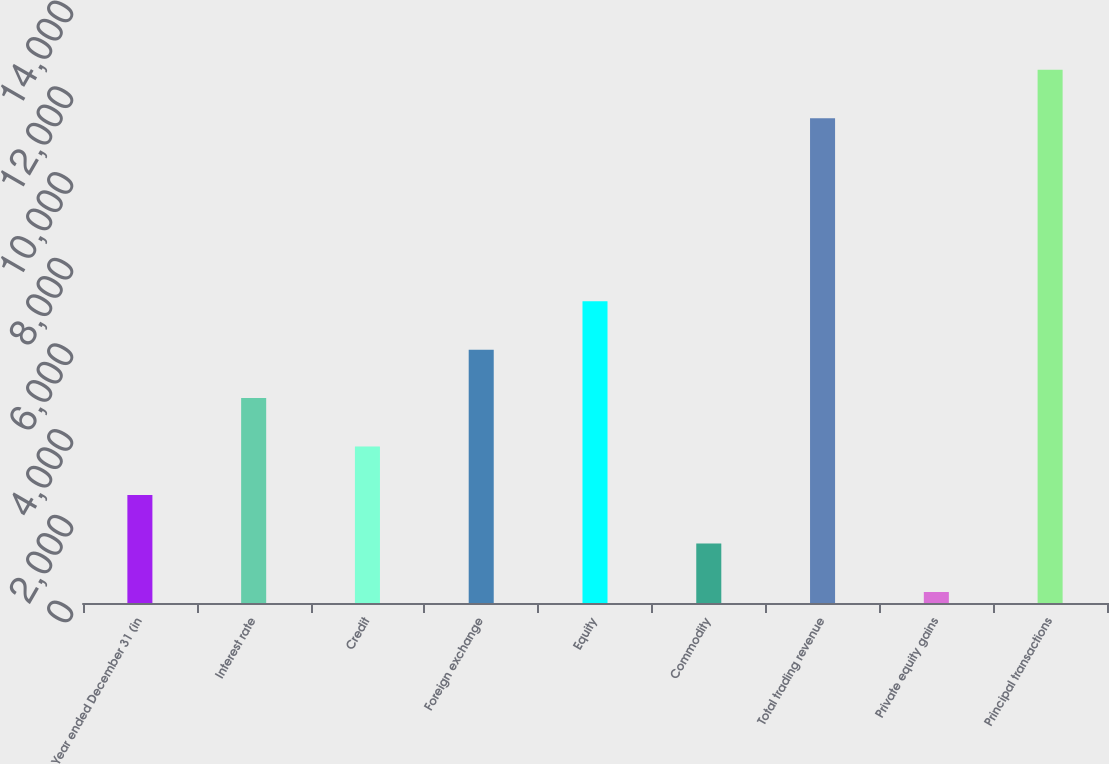<chart> <loc_0><loc_0><loc_500><loc_500><bar_chart><fcel>Year ended December 31 (in<fcel>Interest rate<fcel>Credit<fcel>Foreign exchange<fcel>Equity<fcel>Commodity<fcel>Total trading revenue<fcel>Private equity gains<fcel>Principal transactions<nl><fcel>2518.8<fcel>4780.6<fcel>3649.7<fcel>5911.5<fcel>7042.4<fcel>1387.9<fcel>11309<fcel>257<fcel>12439.9<nl></chart> 